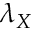Convert formula to latex. <formula><loc_0><loc_0><loc_500><loc_500>\lambda _ { X }</formula> 